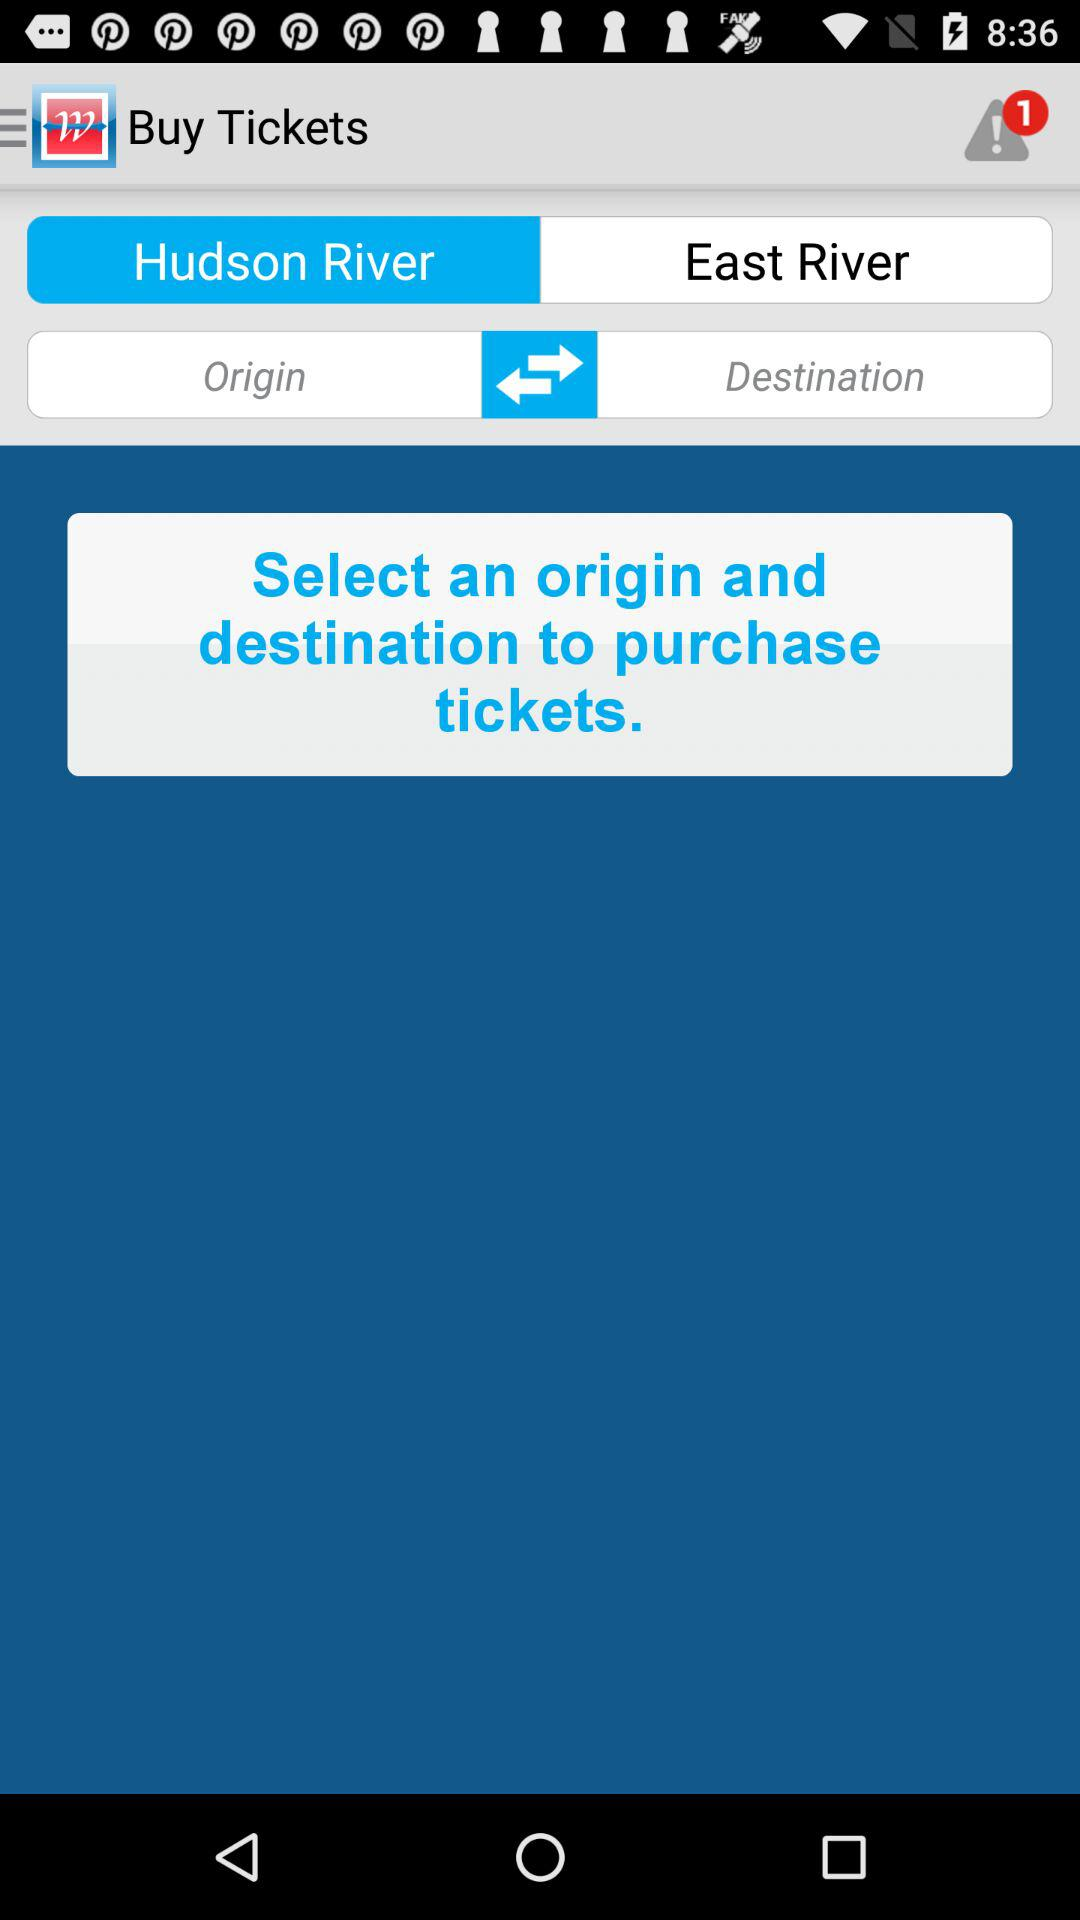What is the origin point? The origin point is the Hudson River. 